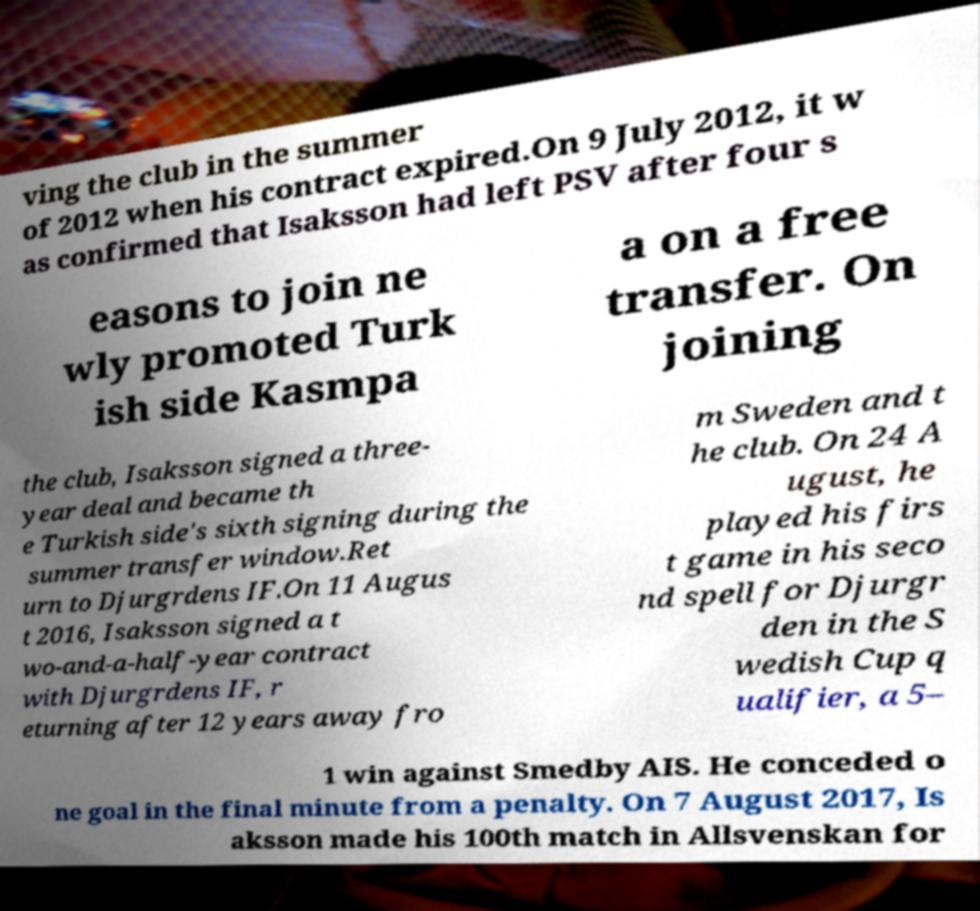For documentation purposes, I need the text within this image transcribed. Could you provide that? ving the club in the summer of 2012 when his contract expired.On 9 July 2012, it w as confirmed that Isaksson had left PSV after four s easons to join ne wly promoted Turk ish side Kasmpa a on a free transfer. On joining the club, Isaksson signed a three- year deal and became th e Turkish side's sixth signing during the summer transfer window.Ret urn to Djurgrdens IF.On 11 Augus t 2016, Isaksson signed a t wo-and-a-half-year contract with Djurgrdens IF, r eturning after 12 years away fro m Sweden and t he club. On 24 A ugust, he played his firs t game in his seco nd spell for Djurgr den in the S wedish Cup q ualifier, a 5– 1 win against Smedby AIS. He conceded o ne goal in the final minute from a penalty. On 7 August 2017, Is aksson made his 100th match in Allsvenskan for 